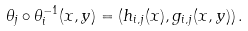Convert formula to latex. <formula><loc_0><loc_0><loc_500><loc_500>\theta _ { j } \circ \theta _ { i } ^ { - 1 } ( x , y ) = ( h _ { i , j } ( x ) , g _ { i , j } ( x , y ) ) \, .</formula> 